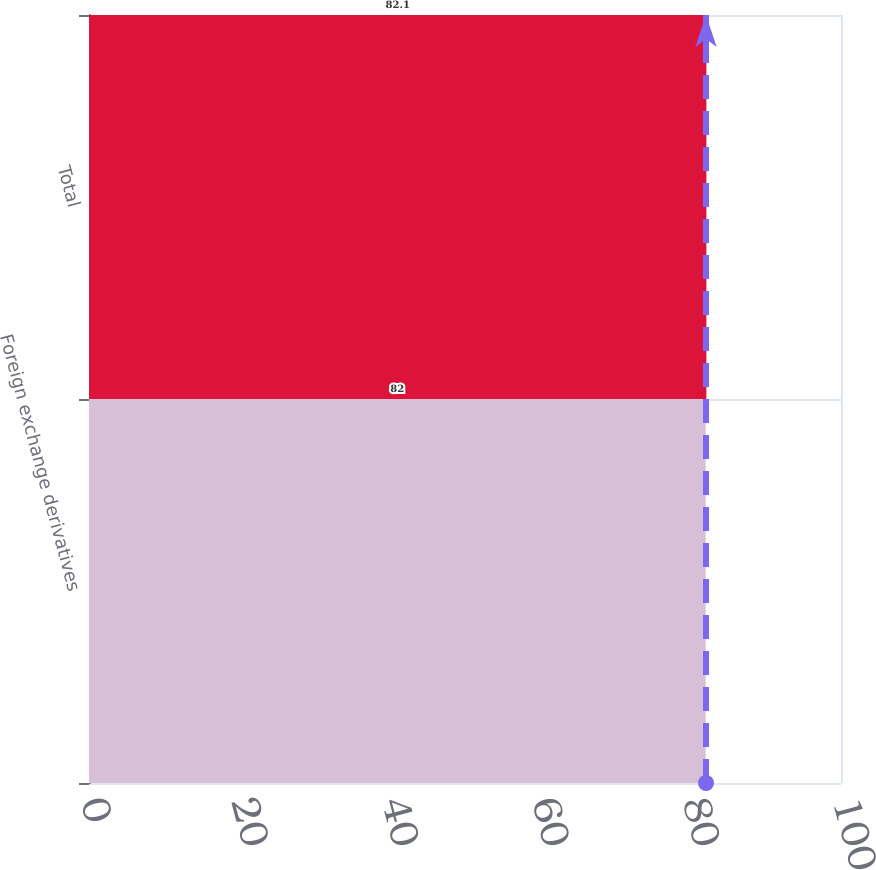Convert chart. <chart><loc_0><loc_0><loc_500><loc_500><bar_chart><fcel>Foreign exchange derivatives<fcel>Total<nl><fcel>82<fcel>82.1<nl></chart> 